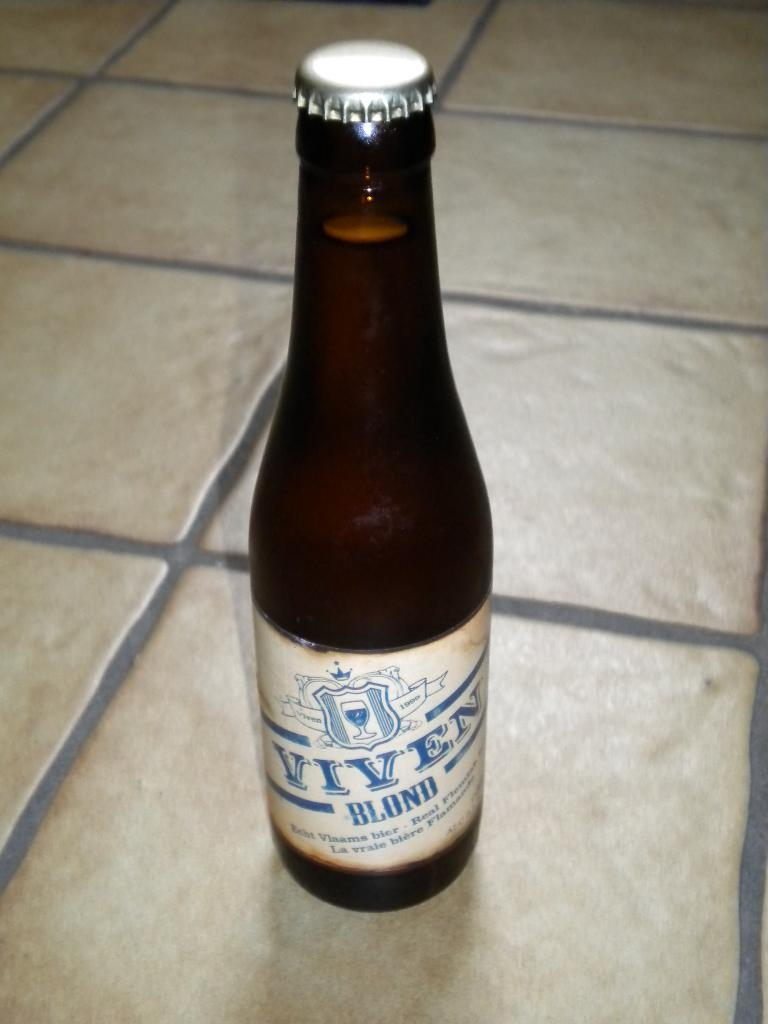Provide a one-sentence caption for the provided image. A beer bottle of Viven Blond with the bottlecap still on. 